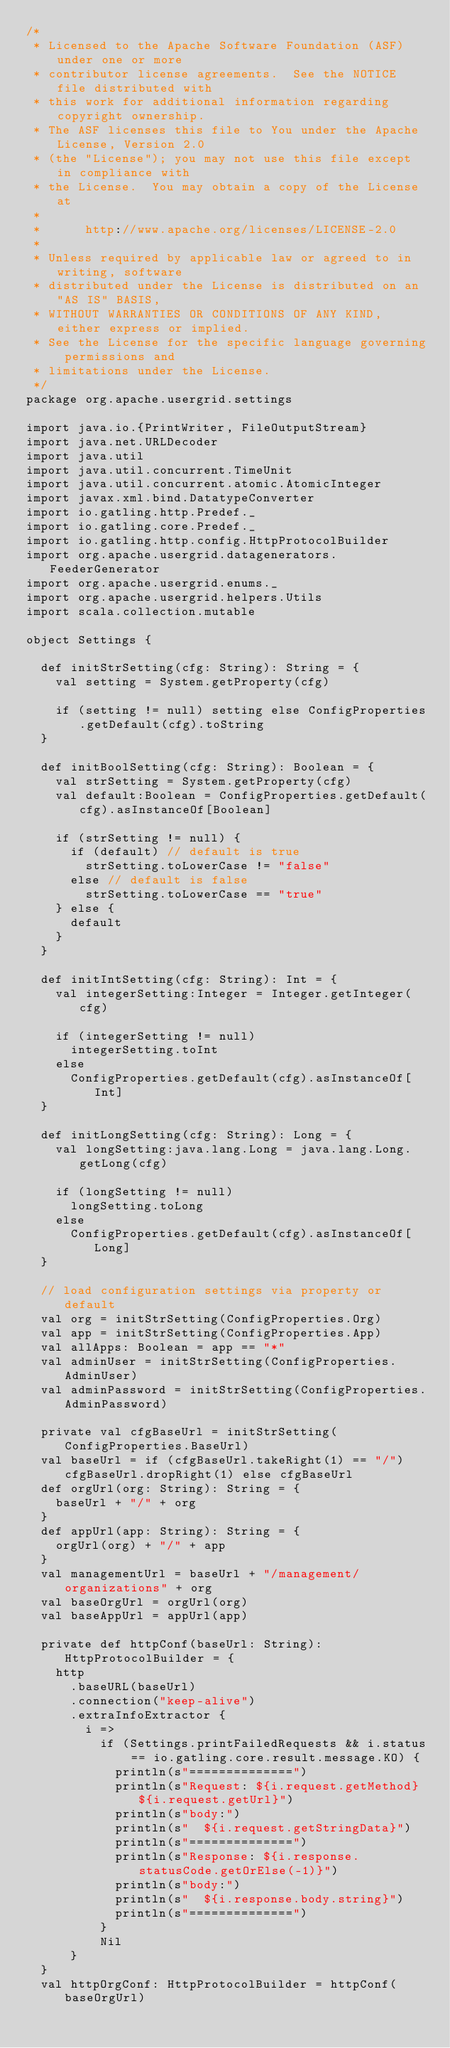Convert code to text. <code><loc_0><loc_0><loc_500><loc_500><_Scala_>/*
 * Licensed to the Apache Software Foundation (ASF) under one or more
 * contributor license agreements.  See the NOTICE file distributed with
 * this work for additional information regarding copyright ownership.
 * The ASF licenses this file to You under the Apache License, Version 2.0
 * (the "License"); you may not use this file except in compliance with
 * the License.  You may obtain a copy of the License at
 *
 *      http://www.apache.org/licenses/LICENSE-2.0
 *
 * Unless required by applicable law or agreed to in writing, software
 * distributed under the License is distributed on an "AS IS" BASIS,
 * WITHOUT WARRANTIES OR CONDITIONS OF ANY KIND, either express or implied.
 * See the License for the specific language governing permissions and
 * limitations under the License.
 */
package org.apache.usergrid.settings

import java.io.{PrintWriter, FileOutputStream}
import java.net.URLDecoder
import java.util
import java.util.concurrent.TimeUnit
import java.util.concurrent.atomic.AtomicInteger
import javax.xml.bind.DatatypeConverter
import io.gatling.http.Predef._
import io.gatling.core.Predef._
import io.gatling.http.config.HttpProtocolBuilder
import org.apache.usergrid.datagenerators.FeederGenerator
import org.apache.usergrid.enums._
import org.apache.usergrid.helpers.Utils
import scala.collection.mutable

object Settings {

  def initStrSetting(cfg: String): String = {
    val setting = System.getProperty(cfg)

    if (setting != null) setting else ConfigProperties.getDefault(cfg).toString
  }

  def initBoolSetting(cfg: String): Boolean = {
    val strSetting = System.getProperty(cfg)
    val default:Boolean = ConfigProperties.getDefault(cfg).asInstanceOf[Boolean]

    if (strSetting != null) {
      if (default) // default is true
        strSetting.toLowerCase != "false"
      else // default is false
        strSetting.toLowerCase == "true"
    } else {
      default
    }
  }

  def initIntSetting(cfg: String): Int = {
    val integerSetting:Integer = Integer.getInteger(cfg)

    if (integerSetting != null)
      integerSetting.toInt
    else
      ConfigProperties.getDefault(cfg).asInstanceOf[Int]
  }

  def initLongSetting(cfg: String): Long = {
    val longSetting:java.lang.Long = java.lang.Long.getLong(cfg)

    if (longSetting != null)
      longSetting.toLong
    else
      ConfigProperties.getDefault(cfg).asInstanceOf[Long]
  }

  // load configuration settings via property or default
  val org = initStrSetting(ConfigProperties.Org)
  val app = initStrSetting(ConfigProperties.App)
  val allApps: Boolean = app == "*"
  val adminUser = initStrSetting(ConfigProperties.AdminUser)
  val adminPassword = initStrSetting(ConfigProperties.AdminPassword)

  private val cfgBaseUrl = initStrSetting(ConfigProperties.BaseUrl)
  val baseUrl = if (cfgBaseUrl.takeRight(1) == "/") cfgBaseUrl.dropRight(1) else cfgBaseUrl
  def orgUrl(org: String): String = {
    baseUrl + "/" + org
  }
  def appUrl(app: String): String = {
    orgUrl(org) + "/" + app
  }
  val managementUrl = baseUrl + "/management/organizations" + org
  val baseOrgUrl = orgUrl(org)
  val baseAppUrl = appUrl(app)

  private def httpConf(baseUrl: String): HttpProtocolBuilder = {
    http
      .baseURL(baseUrl)
      .connection("keep-alive")
      .extraInfoExtractor {
        i =>
          if (Settings.printFailedRequests && i.status == io.gatling.core.result.message.KO) {
            println(s"==============")
            println(s"Request: ${i.request.getMethod} ${i.request.getUrl}")
            println(s"body:")
            println(s"  ${i.request.getStringData}")
            println(s"==============")
            println(s"Response: ${i.response.statusCode.getOrElse(-1)}")
            println(s"body:")
            println(s"  ${i.response.body.string}")
            println(s"==============")
          }
          Nil
      }
  }
  val httpOrgConf: HttpProtocolBuilder = httpConf(baseOrgUrl)</code> 